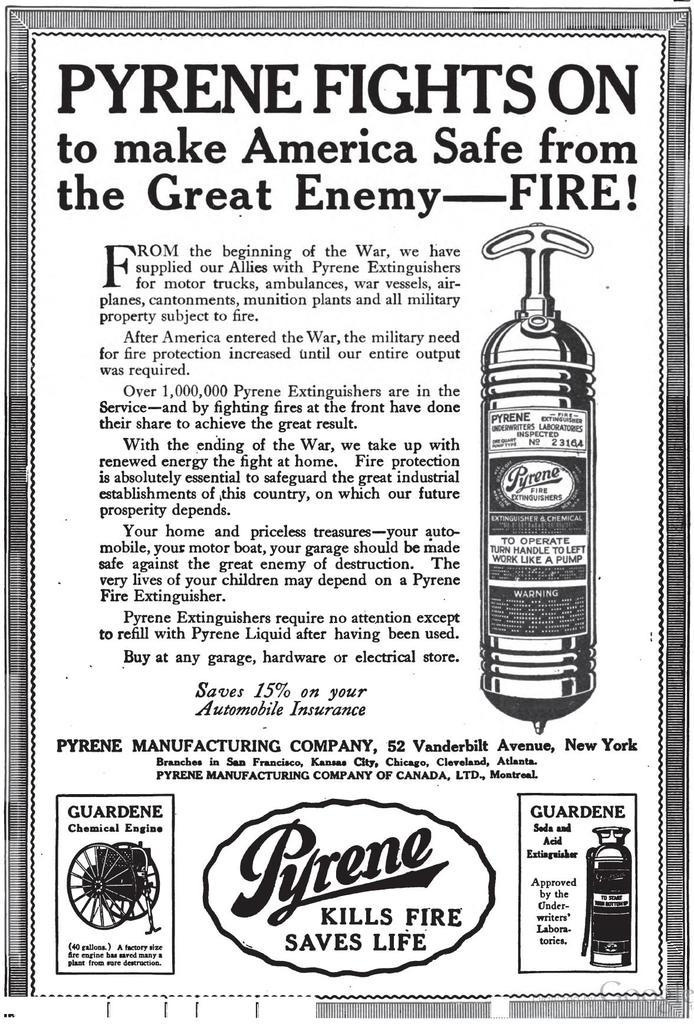What is present on the paper in the image? There is writing on the paper in the image. Can you describe the objects visible in the image? Unfortunately, the provided facts do not specify the objects visible in the image. What is the purpose of the writing on the paper? The purpose of the writing on the paper cannot be determined from the provided facts. How does the earthquake affect the paper in the image? There is no earthquake present in the image, so its effects cannot be determined. 